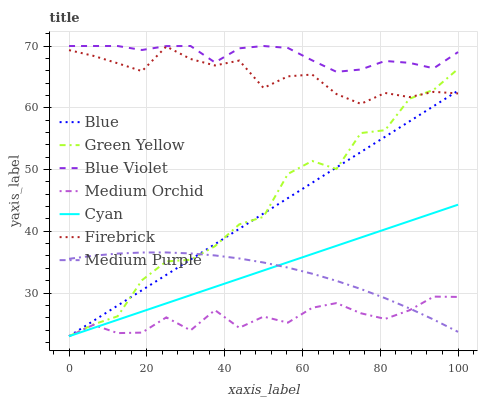Does Medium Orchid have the minimum area under the curve?
Answer yes or no. Yes. Does Firebrick have the minimum area under the curve?
Answer yes or no. No. Does Firebrick have the maximum area under the curve?
Answer yes or no. No. Is Firebrick the smoothest?
Answer yes or no. No. Is Firebrick the roughest?
Answer yes or no. No. Does Firebrick have the lowest value?
Answer yes or no. No. Does Firebrick have the highest value?
Answer yes or no. No. Is Medium Orchid less than Blue Violet?
Answer yes or no. Yes. Is Blue Violet greater than Green Yellow?
Answer yes or no. Yes. Does Medium Orchid intersect Blue Violet?
Answer yes or no. No. 